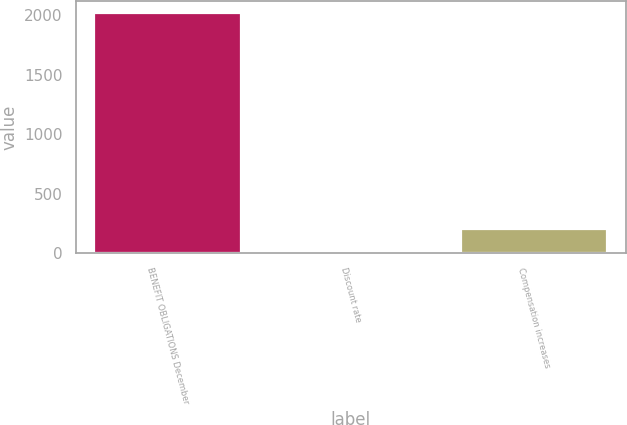Convert chart to OTSL. <chart><loc_0><loc_0><loc_500><loc_500><bar_chart><fcel>BENEFIT OBLIGATIONS December<fcel>Discount rate<fcel>Compensation increases<nl><fcel>2017<fcel>2.45<fcel>203.91<nl></chart> 